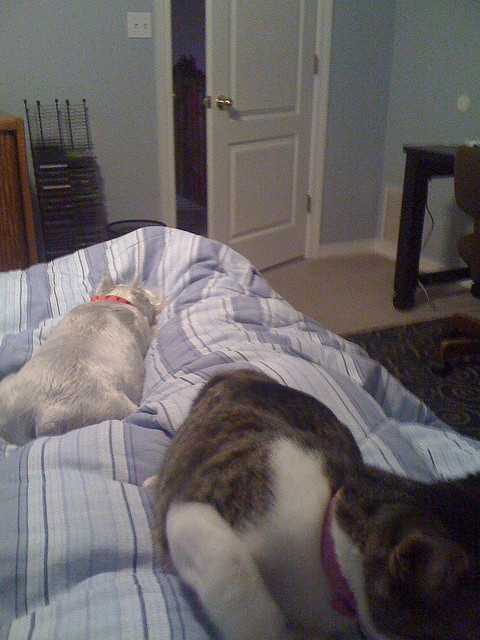Describe the objects in this image and their specific colors. I can see bed in gray, darkgray, and lightgray tones, cat in gray and black tones, cat in gray and darkgray tones, dog in gray and darkgray tones, and dining table in gray, black, navy, and darkgreen tones in this image. 